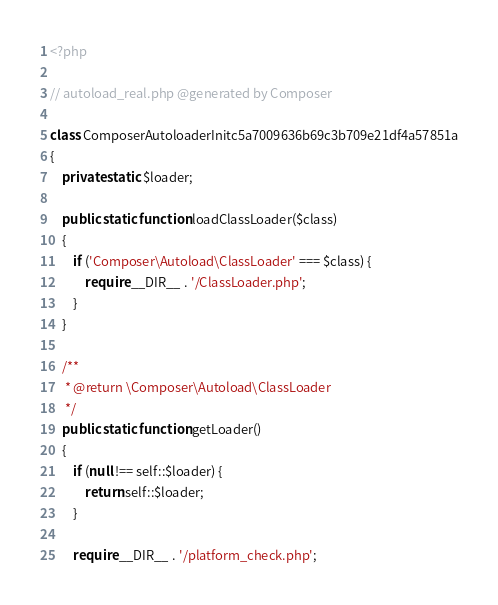Convert code to text. <code><loc_0><loc_0><loc_500><loc_500><_PHP_><?php

// autoload_real.php @generated by Composer

class ComposerAutoloaderInitc5a7009636b69c3b709e21df4a57851a
{
    private static $loader;

    public static function loadClassLoader($class)
    {
        if ('Composer\Autoload\ClassLoader' === $class) {
            require __DIR__ . '/ClassLoader.php';
        }
    }

    /**
     * @return \Composer\Autoload\ClassLoader
     */
    public static function getLoader()
    {
        if (null !== self::$loader) {
            return self::$loader;
        }

        require __DIR__ . '/platform_check.php';
</code> 